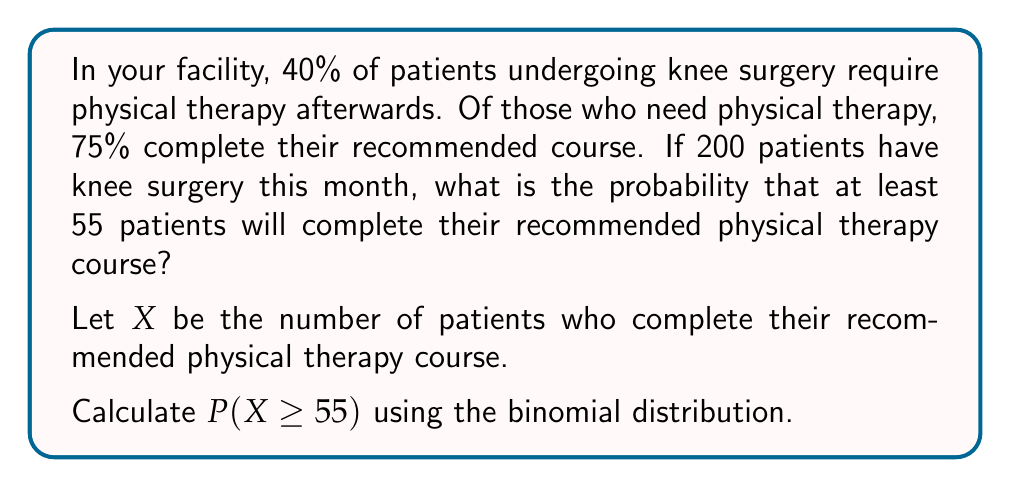Could you help me with this problem? To solve this problem, we'll follow these steps:

1) Identify the parameters of the binomial distribution:
   n = 200 (total number of knee surgery patients)
   p = 0.40 × 0.75 = 0.30 (probability of a patient completing PT)

2) We need to find P(X ≥ 55). This is equivalent to 1 - P(X < 55) or 1 - P(X ≤ 54)

3) Use the cumulative binomial probability function:

   $$P(X \leq 54) = \sum_{k=0}^{54} \binom{200}{k} (0.30)^k (0.70)^{200-k}$$

4) This sum is difficult to calculate by hand, so we would typically use statistical software or a calculator with a binomial cumulative distribution function.

5) Using such a tool, we find that P(X ≤ 54) ≈ 0.1841

6) Therefore, P(X ≥ 55) = 1 - P(X ≤ 54) ≈ 1 - 0.1841 = 0.8159

So, the probability that at least 55 patients will complete their recommended physical therapy course is approximately 0.8159 or 81.59%.
Answer: 0.8159 